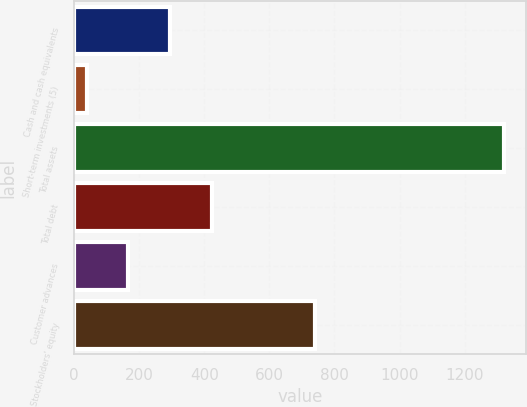Convert chart to OTSL. <chart><loc_0><loc_0><loc_500><loc_500><bar_chart><fcel>Cash and cash equivalents<fcel>Short-term investments (5)<fcel>Total assets<fcel>Total debt<fcel>Customer advances<fcel>Stockholders' equity<nl><fcel>295.06<fcel>38.4<fcel>1321.7<fcel>423.39<fcel>166.73<fcel>740.9<nl></chart> 